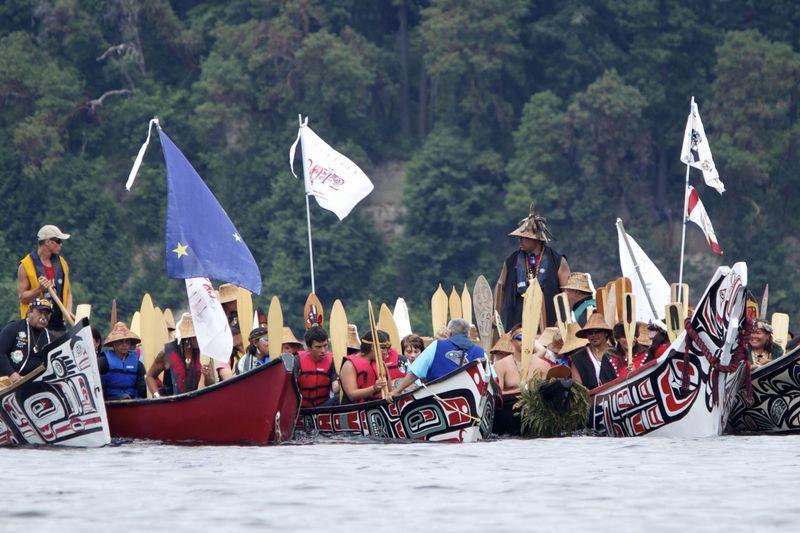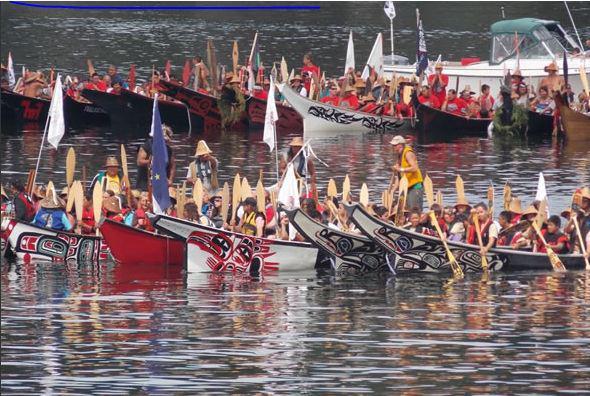The first image is the image on the left, the second image is the image on the right. Given the left and right images, does the statement "At least half a dozen boats sit in the water in the image on the right." hold true? Answer yes or no. Yes. The first image is the image on the left, the second image is the image on the right. Examine the images to the left and right. Is the description "One of the images contains three or less boats." accurate? Answer yes or no. No. 